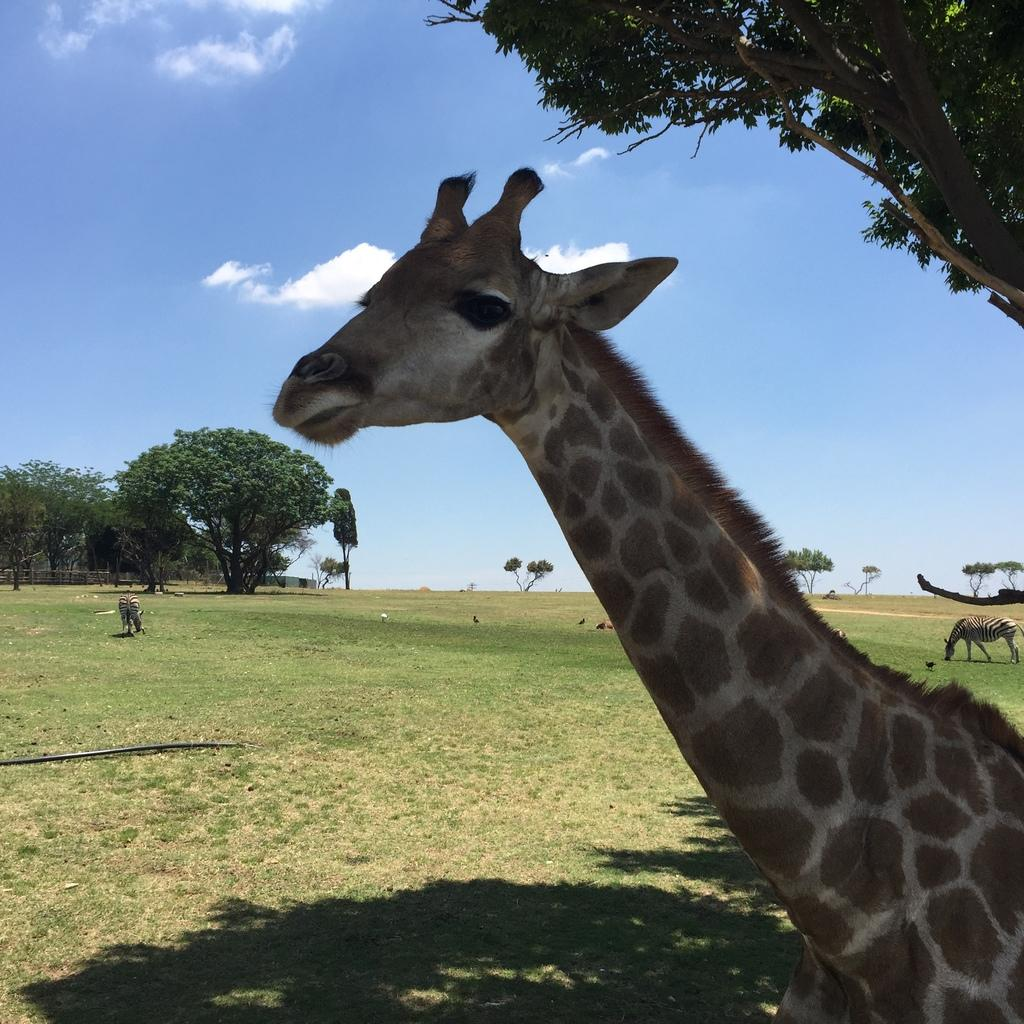What type of animal is the main subject of the image? There is a giraffe in the image. What other animals can be seen in the image? There are animals in the background of the image. What type of vegetation is visible in the image? There are trees visible in the image. What is the ground covered with in the image? Grass is present on the ground in the image. What is visible at the top of the image? The sky is visible at the top of the image. What can be seen in the sky in the image? Clouds are present in the sky. How many brothers does the giraffe have in the image? There is no information about the giraffe's brothers in the image. Who is the secretary of the animals in the image? There is no secretary mentioned or depicted in the image. 